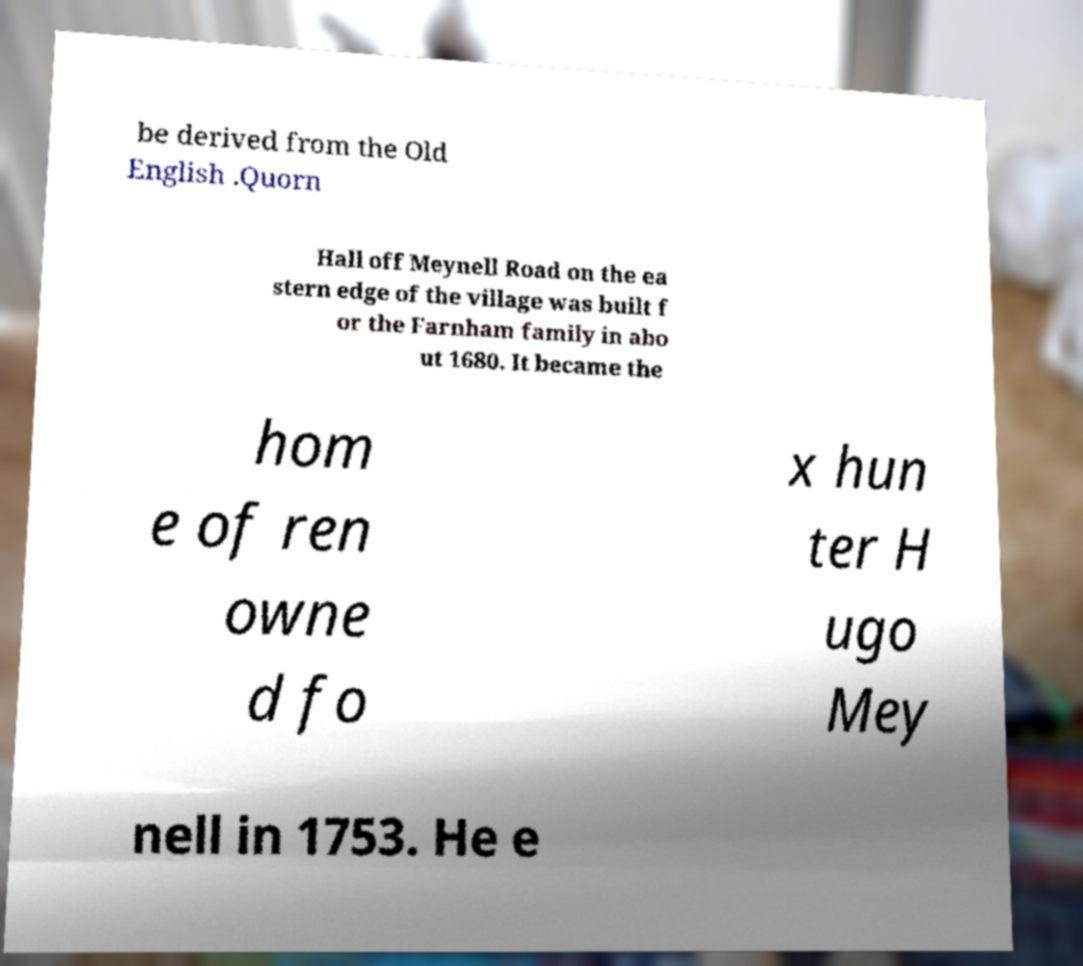Could you assist in decoding the text presented in this image and type it out clearly? be derived from the Old English .Quorn Hall off Meynell Road on the ea stern edge of the village was built f or the Farnham family in abo ut 1680. It became the hom e of ren owne d fo x hun ter H ugo Mey nell in 1753. He e 